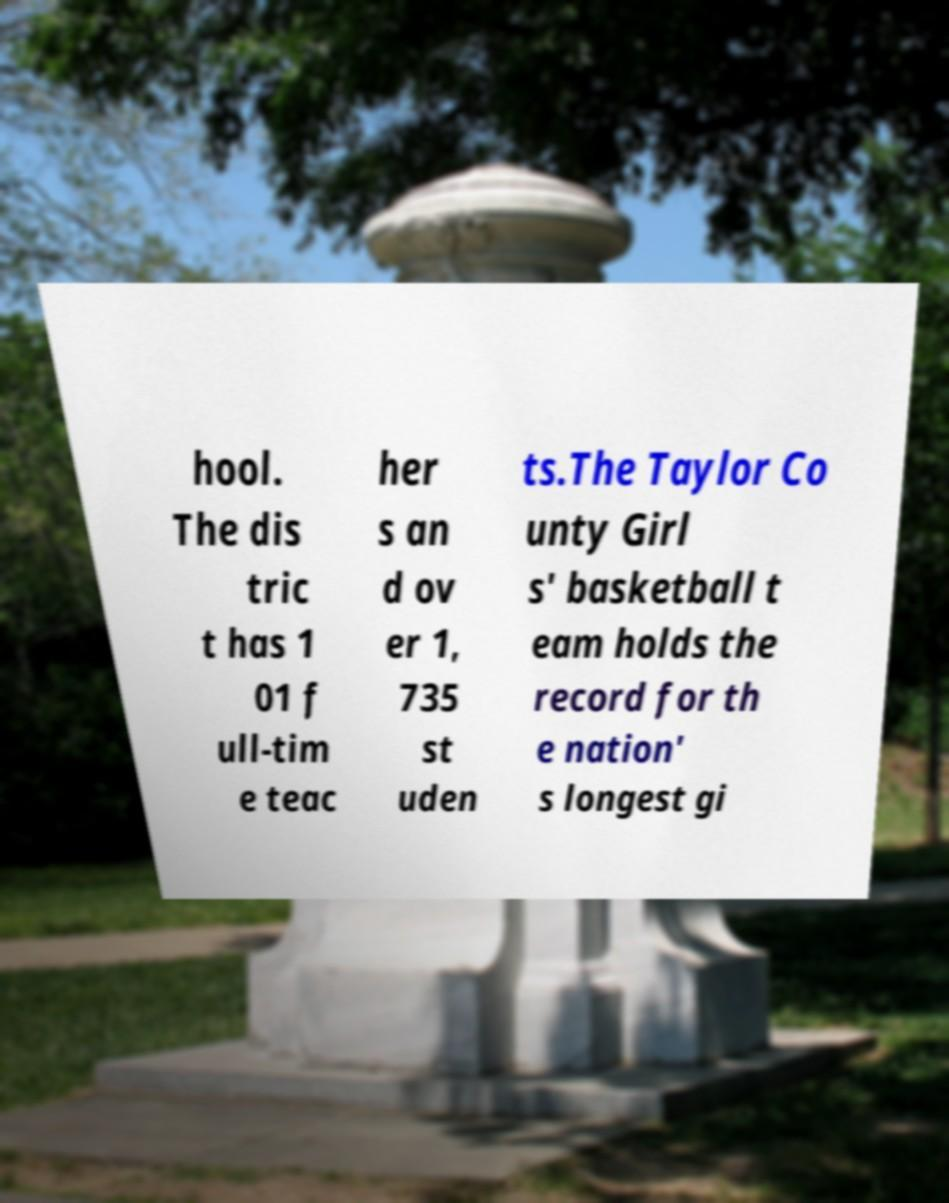Please identify and transcribe the text found in this image. hool. The dis tric t has 1 01 f ull-tim e teac her s an d ov er 1, 735 st uden ts.The Taylor Co unty Girl s' basketball t eam holds the record for th e nation' s longest gi 